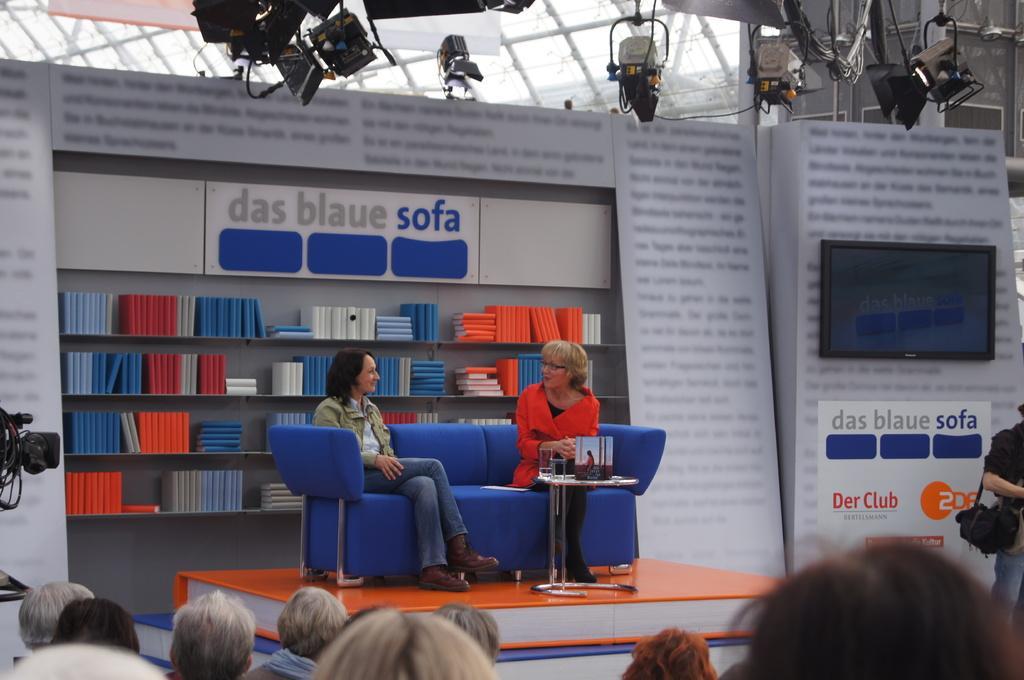How would you summarize this image in a sentence or two? This is a picture in a hall, the two women are sitting on the blue sofa backside of this two people there is a shelf with books. In front of them there are women's and persons. This is a camera. 